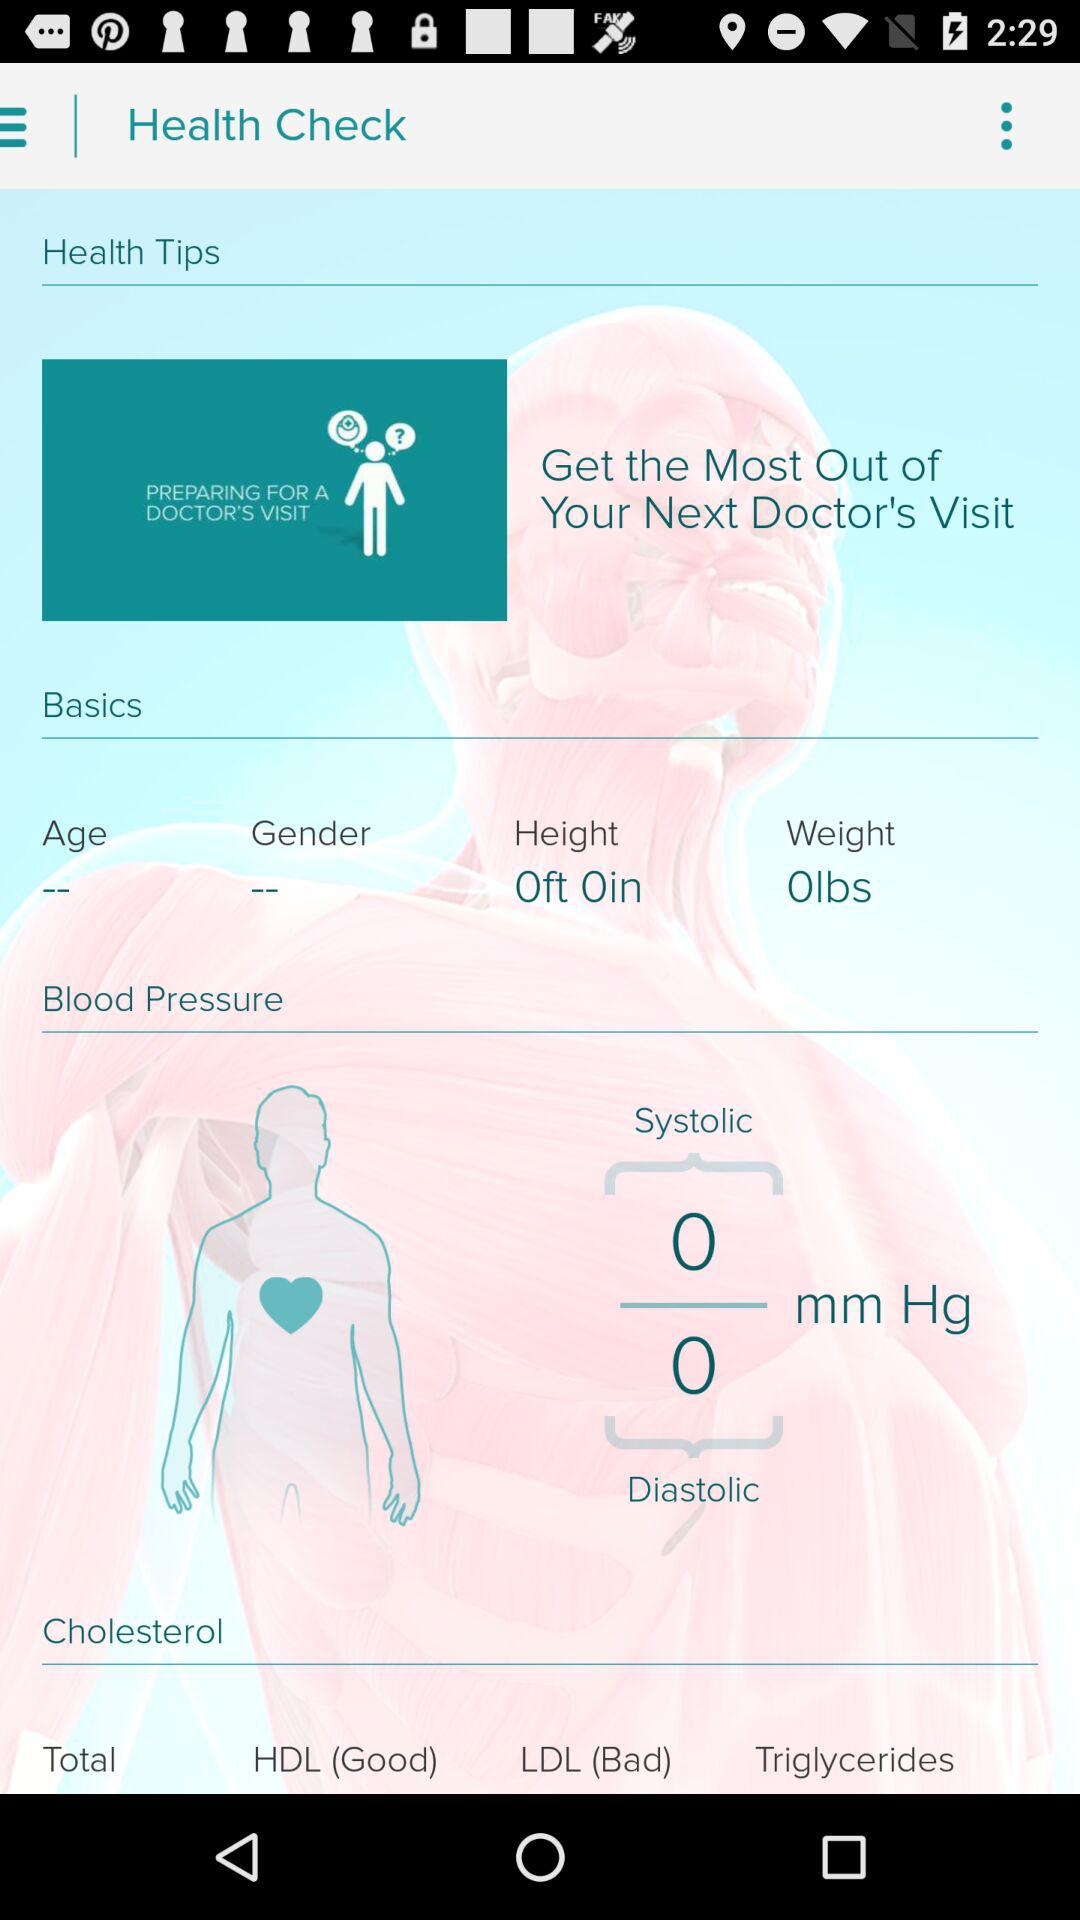What is the weight? The weight is 0 lbs. 